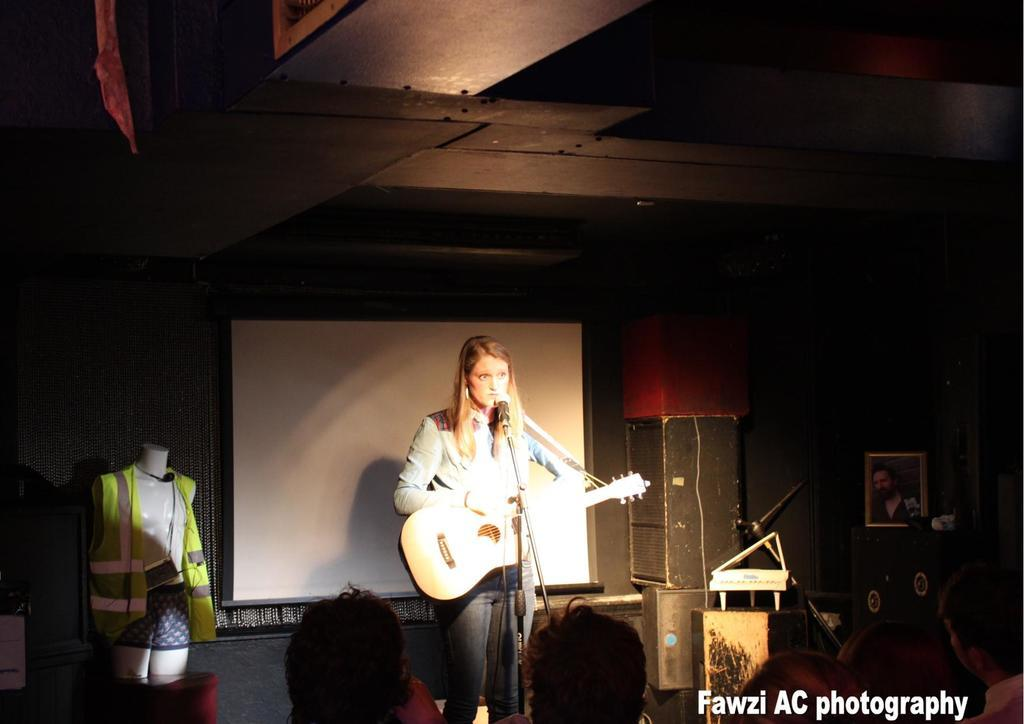What is the main subject of the image? There is a woman in the image. What is the woman doing in the image? The woman is standing and holding a guitar. What equipment is present in the image related to music? There is a microphone and a microphone stand in the image. What can be seen in the background of the image? There is a banner in the background of the image. Can you describe the loaf of bread on the table in the image? There is no loaf of bread present in the image. How does the woman win the fight in the image? There is no fight depicted in the image, and the woman is not engaged in any conflict. 